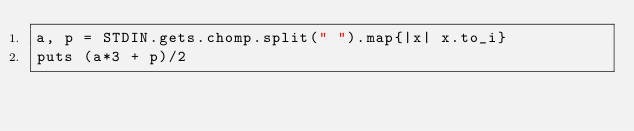Convert code to text. <code><loc_0><loc_0><loc_500><loc_500><_Ruby_>a, p = STDIN.gets.chomp.split(" ").map{|x| x.to_i}
puts (a*3 + p)/2</code> 